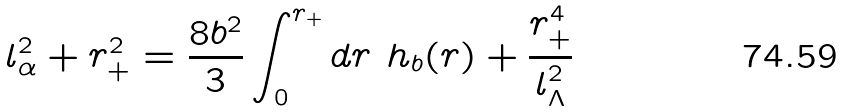Convert formula to latex. <formula><loc_0><loc_0><loc_500><loc_500>l ^ { 2 } _ { \alpha } + r _ { + } ^ { 2 } = \frac { 8 b ^ { 2 } } { 3 } \int _ { 0 } ^ { r _ { + } } d r \ h _ { b } ( r ) + \frac { r _ { + } ^ { 4 } } { l ^ { 2 } _ { \Lambda } }</formula> 